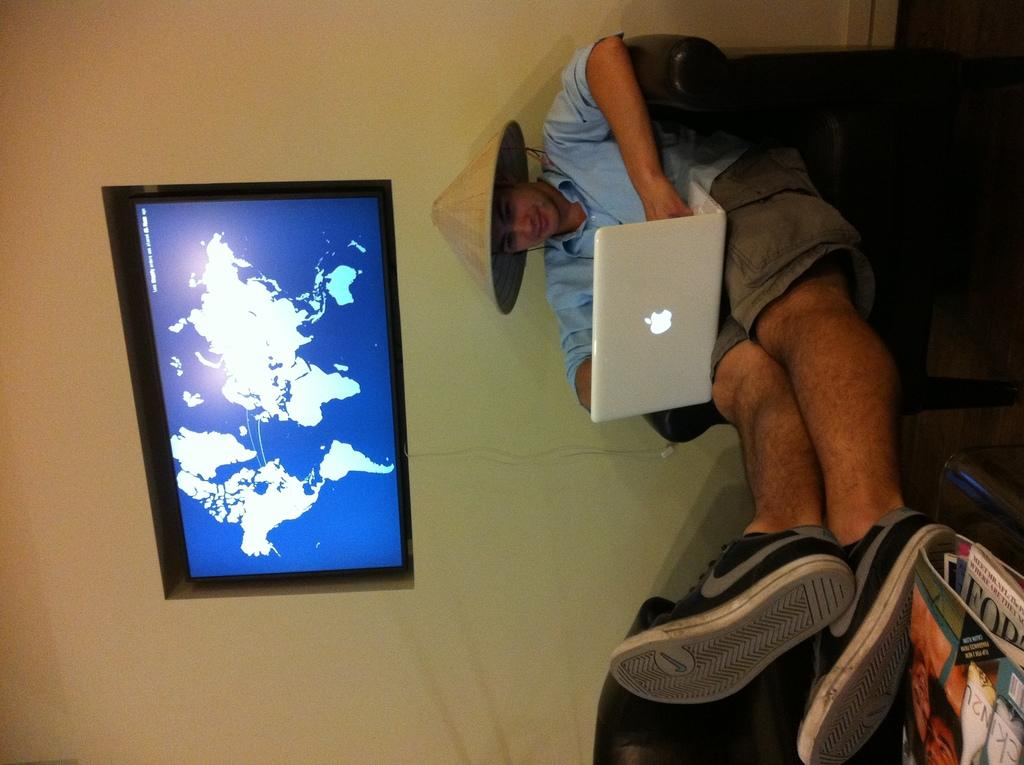What is the person in the image doing? The person is sitting on a sofa. What object is the person holding or using? The person has a laptop on their lap. What can be seen on the right side of the image? There are books on the right side of the image. What type of electronic device is on the wall? There is a television on the wall. What type of fork can be seen in the person's hand in the image? There is no fork present in the image; the person is using a laptop. 